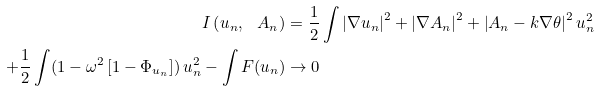Convert formula to latex. <formula><loc_0><loc_0><loc_500><loc_500>I \left ( u _ { n } , \ A _ { n } \right ) & = \frac { 1 } { 2 } \int \left | \nabla u _ { n } \right | ^ { 2 } + \left | \nabla A _ { n } \right | ^ { 2 } + \left | A _ { n } - k \nabla \theta \right | ^ { 2 } u _ { n } ^ { 2 } \\ + \frac { 1 } { 2 } \int ( 1 - \omega ^ { 2 } \left [ 1 - \Phi _ { u _ { n } } \right ] ) \, u _ { n } ^ { 2 } - \int F ( u _ { n } ) & \rightarrow 0</formula> 